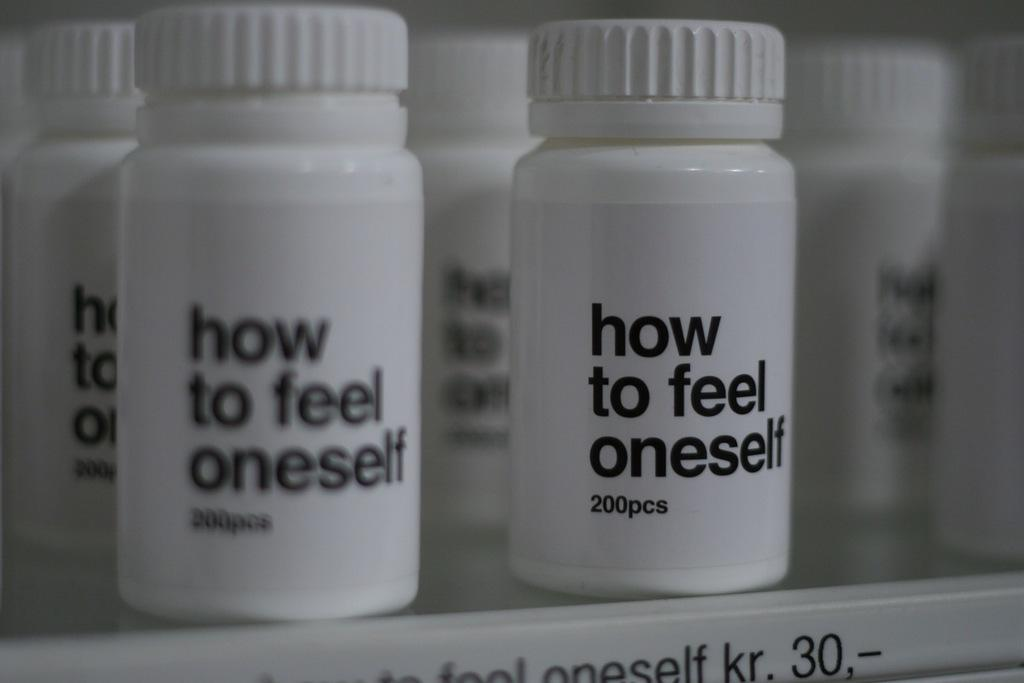Provide a one-sentence caption for the provided image. Pill bottles with the words "How to feel oneself" 200 pcs. 